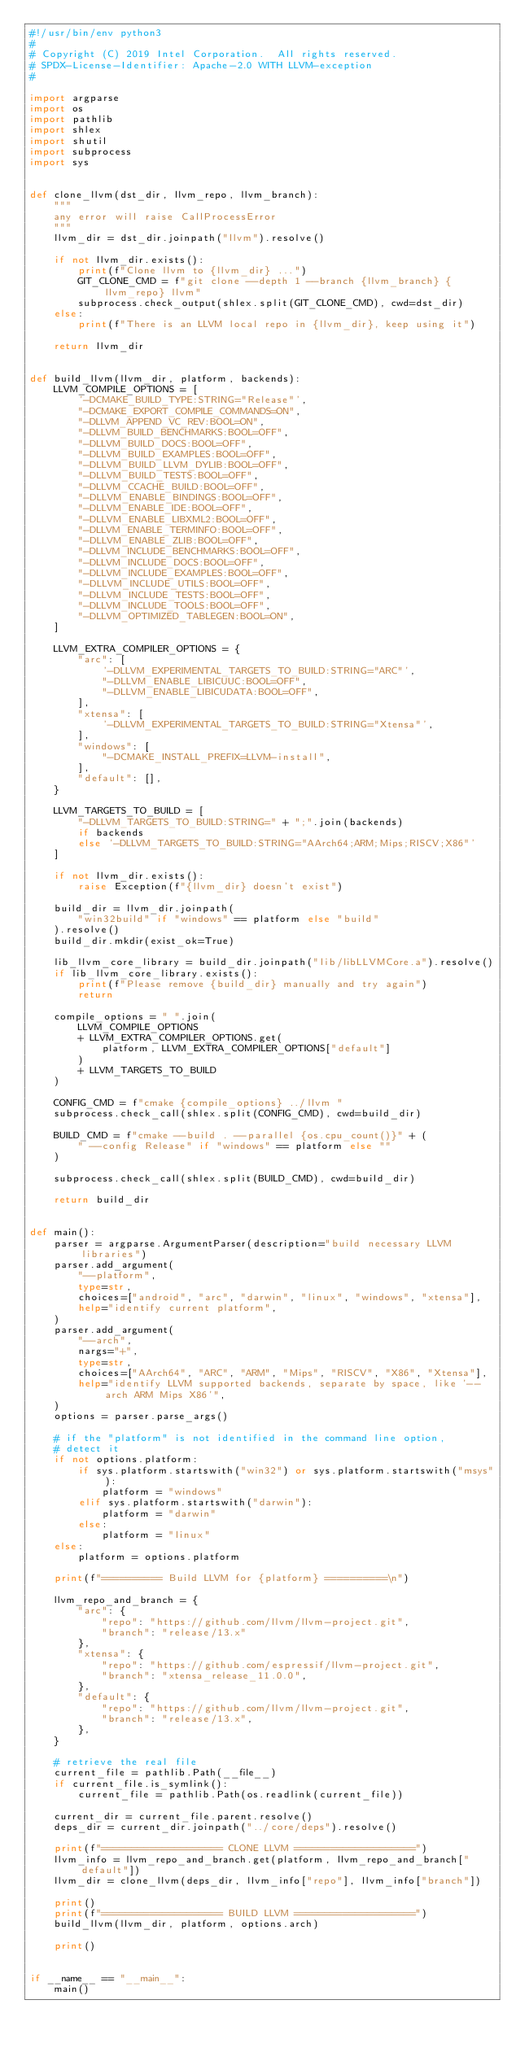Convert code to text. <code><loc_0><loc_0><loc_500><loc_500><_Python_>#!/usr/bin/env python3
#
# Copyright (C) 2019 Intel Corporation.  All rights reserved.
# SPDX-License-Identifier: Apache-2.0 WITH LLVM-exception
#

import argparse
import os
import pathlib
import shlex
import shutil
import subprocess
import sys


def clone_llvm(dst_dir, llvm_repo, llvm_branch):
    """
    any error will raise CallProcessError
    """
    llvm_dir = dst_dir.joinpath("llvm").resolve()

    if not llvm_dir.exists():
        print(f"Clone llvm to {llvm_dir} ...")
        GIT_CLONE_CMD = f"git clone --depth 1 --branch {llvm_branch} {llvm_repo} llvm"
        subprocess.check_output(shlex.split(GIT_CLONE_CMD), cwd=dst_dir)
    else:
        print(f"There is an LLVM local repo in {llvm_dir}, keep using it")

    return llvm_dir


def build_llvm(llvm_dir, platform, backends):
    LLVM_COMPILE_OPTIONS = [
        '-DCMAKE_BUILD_TYPE:STRING="Release"',
        "-DCMAKE_EXPORT_COMPILE_COMMANDS=ON",
        "-DLLVM_APPEND_VC_REV:BOOL=ON",
        "-DLLVM_BUILD_BENCHMARKS:BOOL=OFF",
        "-DLLVM_BUILD_DOCS:BOOL=OFF",
        "-DLLVM_BUILD_EXAMPLES:BOOL=OFF",
        "-DLLVM_BUILD_LLVM_DYLIB:BOOL=OFF",
        "-DLLVM_BUILD_TESTS:BOOL=OFF",
        "-DLLVM_CCACHE_BUILD:BOOL=OFF",
        "-DLLVM_ENABLE_BINDINGS:BOOL=OFF",
        "-DLLVM_ENABLE_IDE:BOOL=OFF",
        "-DLLVM_ENABLE_LIBXML2:BOOL=OFF",
        "-DLLVM_ENABLE_TERMINFO:BOOL=OFF",
        "-DLLVM_ENABLE_ZLIB:BOOL=OFF",
        "-DLLVM_INCLUDE_BENCHMARKS:BOOL=OFF",
        "-DLLVM_INCLUDE_DOCS:BOOL=OFF",
        "-DLLVM_INCLUDE_EXAMPLES:BOOL=OFF",
        "-DLLVM_INCLUDE_UTILS:BOOL=OFF",
        "-DLLVM_INCLUDE_TESTS:BOOL=OFF",
        "-DLLVM_INCLUDE_TOOLS:BOOL=OFF",
        "-DLLVM_OPTIMIZED_TABLEGEN:BOOL=ON",
    ]

    LLVM_EXTRA_COMPILER_OPTIONS = {
        "arc": [
            '-DLLVM_EXPERIMENTAL_TARGETS_TO_BUILD:STRING="ARC"',
            "-DLLVM_ENABLE_LIBICUUC:BOOL=OFF",
            "-DLLVM_ENABLE_LIBICUDATA:BOOL=OFF",
        ],
        "xtensa": [
            '-DLLVM_EXPERIMENTAL_TARGETS_TO_BUILD:STRING="Xtensa"',
        ],
        "windows": [
            "-DCMAKE_INSTALL_PREFIX=LLVM-install",
        ],
        "default": [],
    }

    LLVM_TARGETS_TO_BUILD = [
        "-DLLVM_TARGETS_TO_BUILD:STRING=" + ";".join(backends)
        if backends
        else '-DLLVM_TARGETS_TO_BUILD:STRING="AArch64;ARM;Mips;RISCV;X86"'
    ]

    if not llvm_dir.exists():
        raise Exception(f"{llvm_dir} doesn't exist")

    build_dir = llvm_dir.joinpath(
        "win32build" if "windows" == platform else "build"
    ).resolve()
    build_dir.mkdir(exist_ok=True)

    lib_llvm_core_library = build_dir.joinpath("lib/libLLVMCore.a").resolve()
    if lib_llvm_core_library.exists():
        print(f"Please remove {build_dir} manually and try again")
        return

    compile_options = " ".join(
        LLVM_COMPILE_OPTIONS
        + LLVM_EXTRA_COMPILER_OPTIONS.get(
            platform, LLVM_EXTRA_COMPILER_OPTIONS["default"]
        )
        + LLVM_TARGETS_TO_BUILD
    )

    CONFIG_CMD = f"cmake {compile_options} ../llvm "
    subprocess.check_call(shlex.split(CONFIG_CMD), cwd=build_dir)

    BUILD_CMD = f"cmake --build . --parallel {os.cpu_count()}" + (
        " --config Release" if "windows" == platform else ""
    )

    subprocess.check_call(shlex.split(BUILD_CMD), cwd=build_dir)

    return build_dir


def main():
    parser = argparse.ArgumentParser(description="build necessary LLVM libraries")
    parser.add_argument(
        "--platform",
        type=str,
        choices=["android", "arc", "darwin", "linux", "windows", "xtensa"],
        help="identify current platform",
    )
    parser.add_argument(
        "--arch",
        nargs="+",
        type=str,
        choices=["AArch64", "ARC", "ARM", "Mips", "RISCV", "X86", "Xtensa"],
        help="identify LLVM supported backends, separate by space, like '--arch ARM Mips X86'",
    )
    options = parser.parse_args()

    # if the "platform" is not identified in the command line option,
    # detect it
    if not options.platform:
        if sys.platform.startswith("win32") or sys.platform.startswith("msys"):
            platform = "windows"
        elif sys.platform.startswith("darwin"):
            platform = "darwin"
        else:
            platform = "linux"
    else:
        platform = options.platform

    print(f"========== Build LLVM for {platform} ==========\n")

    llvm_repo_and_branch = {
        "arc": {
            "repo": "https://github.com/llvm/llvm-project.git",
            "branch": "release/13.x"
        },
        "xtensa": {
            "repo": "https://github.com/espressif/llvm-project.git",
            "branch": "xtensa_release_11.0.0",
        },
        "default": {
            "repo": "https://github.com/llvm/llvm-project.git",
            "branch": "release/13.x",
        },
    }

    # retrieve the real file
    current_file = pathlib.Path(__file__)
    if current_file.is_symlink():
        current_file = pathlib.Path(os.readlink(current_file))

    current_dir = current_file.parent.resolve()
    deps_dir = current_dir.joinpath("../core/deps").resolve()

    print(f"==================== CLONE LLVM ====================")
    llvm_info = llvm_repo_and_branch.get(platform, llvm_repo_and_branch["default"])
    llvm_dir = clone_llvm(deps_dir, llvm_info["repo"], llvm_info["branch"])

    print()
    print(f"==================== BUILD LLVM ====================")
    build_llvm(llvm_dir, platform, options.arch)

    print()


if __name__ == "__main__":
    main()
</code> 